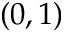<formula> <loc_0><loc_0><loc_500><loc_500>( 0 , 1 )</formula> 